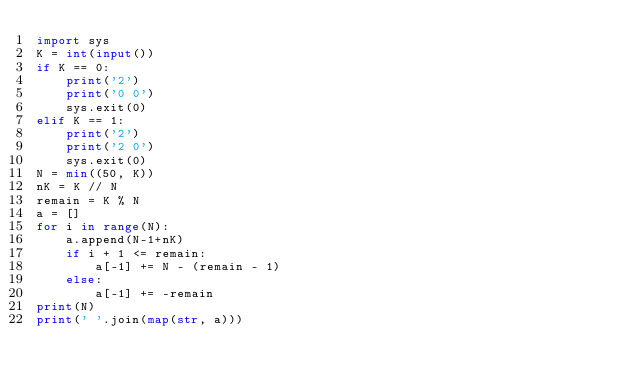<code> <loc_0><loc_0><loc_500><loc_500><_Python_>import sys
K = int(input())
if K == 0:
    print('2')
    print('0 0')
    sys.exit(0)
elif K == 1:
    print('2')
    print('2 0')
    sys.exit(0)
N = min((50, K))
nK = K // N
remain = K % N
a = []
for i in range(N):
    a.append(N-1+nK)
    if i + 1 <= remain:
        a[-1] += N - (remain - 1)
    else:
        a[-1] += -remain
print(N)
print(' '.join(map(str, a)))
</code> 